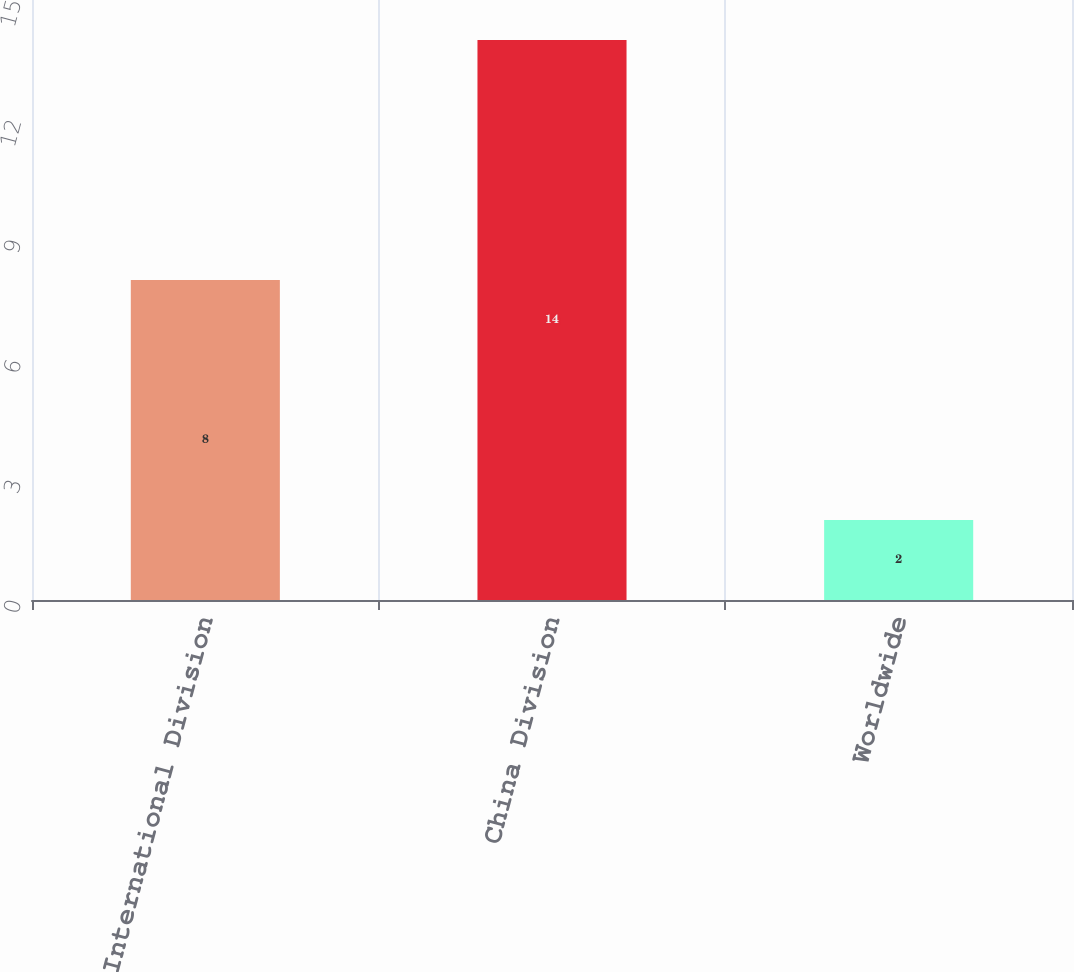Convert chart to OTSL. <chart><loc_0><loc_0><loc_500><loc_500><bar_chart><fcel>International Division<fcel>China Division<fcel>Worldwide<nl><fcel>8<fcel>14<fcel>2<nl></chart> 